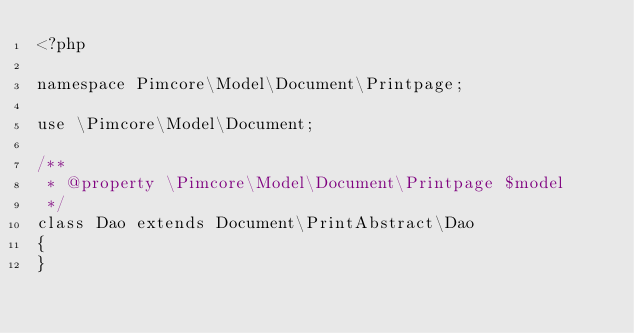<code> <loc_0><loc_0><loc_500><loc_500><_PHP_><?php

namespace Pimcore\Model\Document\Printpage;

use \Pimcore\Model\Document;

/**
 * @property \Pimcore\Model\Document\Printpage $model
 */
class Dao extends Document\PrintAbstract\Dao
{
}
</code> 